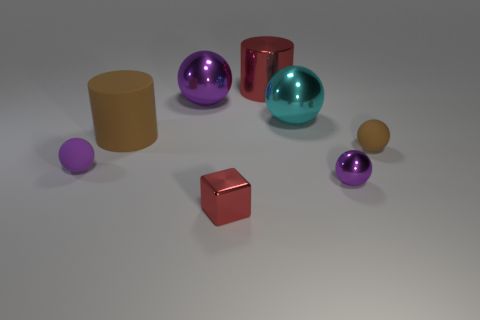Subtract all purple balls. How many balls are left? 2 Add 1 tiny green shiny blocks. How many objects exist? 9 Subtract 1 spheres. How many spheres are left? 4 Subtract all cyan spheres. How many spheres are left? 4 Subtract all blocks. How many objects are left? 7 Subtract 1 brown cylinders. How many objects are left? 7 Subtract all brown blocks. Subtract all gray cylinders. How many blocks are left? 1 Subtract all gray cylinders. How many yellow blocks are left? 0 Subtract all big brown metallic cylinders. Subtract all cyan metal objects. How many objects are left? 7 Add 5 small matte things. How many small matte things are left? 7 